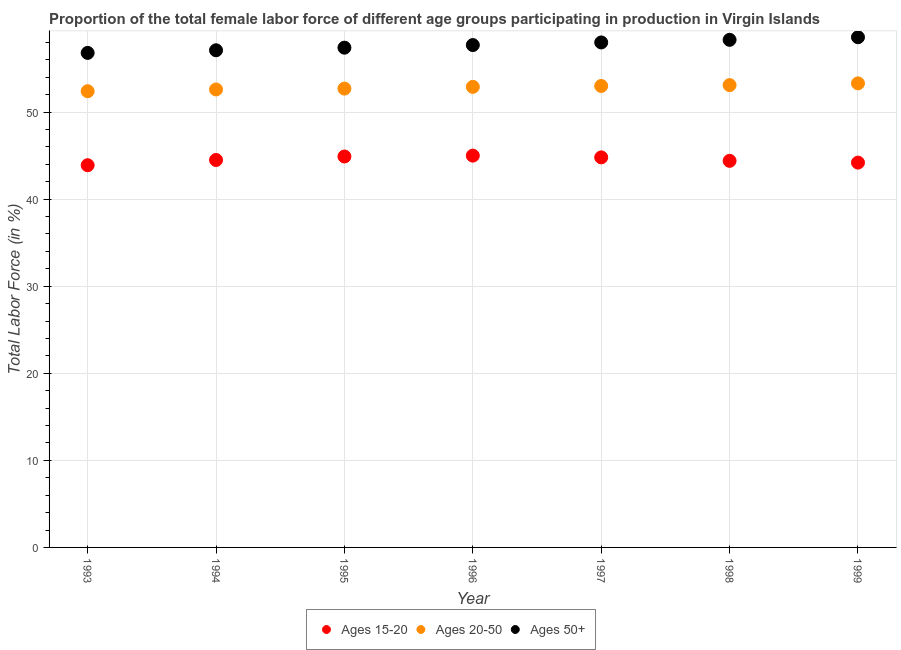How many different coloured dotlines are there?
Make the answer very short. 3. Is the number of dotlines equal to the number of legend labels?
Keep it short and to the point. Yes. What is the percentage of female labor force within the age group 20-50 in 1997?
Your answer should be compact. 53. Across all years, what is the maximum percentage of female labor force within the age group 15-20?
Keep it short and to the point. 45. Across all years, what is the minimum percentage of female labor force within the age group 20-50?
Keep it short and to the point. 52.4. What is the total percentage of female labor force within the age group 20-50 in the graph?
Keep it short and to the point. 370. What is the difference between the percentage of female labor force within the age group 15-20 in 1996 and that in 1997?
Offer a terse response. 0.2. What is the difference between the percentage of female labor force within the age group 15-20 in 1997 and the percentage of female labor force above age 50 in 1993?
Provide a succinct answer. -12. What is the average percentage of female labor force above age 50 per year?
Provide a short and direct response. 57.7. In the year 1997, what is the difference between the percentage of female labor force above age 50 and percentage of female labor force within the age group 15-20?
Make the answer very short. 13.2. What is the ratio of the percentage of female labor force within the age group 15-20 in 1995 to that in 1996?
Keep it short and to the point. 1. What is the difference between the highest and the second highest percentage of female labor force above age 50?
Offer a terse response. 0.3. What is the difference between the highest and the lowest percentage of female labor force within the age group 15-20?
Offer a very short reply. 1.1. Is the sum of the percentage of female labor force within the age group 20-50 in 1996 and 1997 greater than the maximum percentage of female labor force within the age group 15-20 across all years?
Your answer should be very brief. Yes. Is it the case that in every year, the sum of the percentage of female labor force within the age group 15-20 and percentage of female labor force within the age group 20-50 is greater than the percentage of female labor force above age 50?
Keep it short and to the point. Yes. Is the percentage of female labor force within the age group 20-50 strictly greater than the percentage of female labor force within the age group 15-20 over the years?
Offer a very short reply. Yes. How many dotlines are there?
Provide a short and direct response. 3. How many years are there in the graph?
Provide a short and direct response. 7. What is the difference between two consecutive major ticks on the Y-axis?
Keep it short and to the point. 10. Are the values on the major ticks of Y-axis written in scientific E-notation?
Keep it short and to the point. No. Does the graph contain any zero values?
Your response must be concise. No. How are the legend labels stacked?
Your answer should be very brief. Horizontal. What is the title of the graph?
Your answer should be compact. Proportion of the total female labor force of different age groups participating in production in Virgin Islands. Does "Private sector" appear as one of the legend labels in the graph?
Ensure brevity in your answer.  No. What is the label or title of the Y-axis?
Keep it short and to the point. Total Labor Force (in %). What is the Total Labor Force (in %) in Ages 15-20 in 1993?
Provide a succinct answer. 43.9. What is the Total Labor Force (in %) of Ages 20-50 in 1993?
Give a very brief answer. 52.4. What is the Total Labor Force (in %) in Ages 50+ in 1993?
Give a very brief answer. 56.8. What is the Total Labor Force (in %) of Ages 15-20 in 1994?
Offer a terse response. 44.5. What is the Total Labor Force (in %) in Ages 20-50 in 1994?
Make the answer very short. 52.6. What is the Total Labor Force (in %) of Ages 50+ in 1994?
Ensure brevity in your answer.  57.1. What is the Total Labor Force (in %) in Ages 15-20 in 1995?
Keep it short and to the point. 44.9. What is the Total Labor Force (in %) in Ages 20-50 in 1995?
Give a very brief answer. 52.7. What is the Total Labor Force (in %) of Ages 50+ in 1995?
Make the answer very short. 57.4. What is the Total Labor Force (in %) of Ages 20-50 in 1996?
Give a very brief answer. 52.9. What is the Total Labor Force (in %) in Ages 50+ in 1996?
Provide a succinct answer. 57.7. What is the Total Labor Force (in %) in Ages 15-20 in 1997?
Provide a succinct answer. 44.8. What is the Total Labor Force (in %) in Ages 50+ in 1997?
Offer a very short reply. 58. What is the Total Labor Force (in %) in Ages 15-20 in 1998?
Provide a short and direct response. 44.4. What is the Total Labor Force (in %) of Ages 20-50 in 1998?
Keep it short and to the point. 53.1. What is the Total Labor Force (in %) in Ages 50+ in 1998?
Make the answer very short. 58.3. What is the Total Labor Force (in %) in Ages 15-20 in 1999?
Provide a succinct answer. 44.2. What is the Total Labor Force (in %) of Ages 20-50 in 1999?
Make the answer very short. 53.3. What is the Total Labor Force (in %) in Ages 50+ in 1999?
Provide a succinct answer. 58.6. Across all years, what is the maximum Total Labor Force (in %) in Ages 15-20?
Give a very brief answer. 45. Across all years, what is the maximum Total Labor Force (in %) of Ages 20-50?
Provide a succinct answer. 53.3. Across all years, what is the maximum Total Labor Force (in %) in Ages 50+?
Provide a short and direct response. 58.6. Across all years, what is the minimum Total Labor Force (in %) of Ages 15-20?
Offer a terse response. 43.9. Across all years, what is the minimum Total Labor Force (in %) in Ages 20-50?
Keep it short and to the point. 52.4. Across all years, what is the minimum Total Labor Force (in %) in Ages 50+?
Offer a very short reply. 56.8. What is the total Total Labor Force (in %) of Ages 15-20 in the graph?
Keep it short and to the point. 311.7. What is the total Total Labor Force (in %) in Ages 20-50 in the graph?
Offer a terse response. 370. What is the total Total Labor Force (in %) of Ages 50+ in the graph?
Offer a terse response. 403.9. What is the difference between the Total Labor Force (in %) of Ages 15-20 in 1993 and that in 1994?
Give a very brief answer. -0.6. What is the difference between the Total Labor Force (in %) in Ages 20-50 in 1993 and that in 1994?
Offer a terse response. -0.2. What is the difference between the Total Labor Force (in %) in Ages 50+ in 1993 and that in 1995?
Your response must be concise. -0.6. What is the difference between the Total Labor Force (in %) in Ages 15-20 in 1993 and that in 1996?
Ensure brevity in your answer.  -1.1. What is the difference between the Total Labor Force (in %) of Ages 20-50 in 1993 and that in 1996?
Your response must be concise. -0.5. What is the difference between the Total Labor Force (in %) in Ages 15-20 in 1993 and that in 1997?
Ensure brevity in your answer.  -0.9. What is the difference between the Total Labor Force (in %) in Ages 20-50 in 1993 and that in 1997?
Keep it short and to the point. -0.6. What is the difference between the Total Labor Force (in %) in Ages 15-20 in 1993 and that in 1998?
Keep it short and to the point. -0.5. What is the difference between the Total Labor Force (in %) of Ages 20-50 in 1993 and that in 1998?
Make the answer very short. -0.7. What is the difference between the Total Labor Force (in %) of Ages 15-20 in 1993 and that in 1999?
Offer a very short reply. -0.3. What is the difference between the Total Labor Force (in %) of Ages 20-50 in 1993 and that in 1999?
Provide a succinct answer. -0.9. What is the difference between the Total Labor Force (in %) in Ages 15-20 in 1994 and that in 1995?
Ensure brevity in your answer.  -0.4. What is the difference between the Total Labor Force (in %) of Ages 20-50 in 1994 and that in 1995?
Your response must be concise. -0.1. What is the difference between the Total Labor Force (in %) of Ages 20-50 in 1994 and that in 1997?
Ensure brevity in your answer.  -0.4. What is the difference between the Total Labor Force (in %) of Ages 50+ in 1994 and that in 1997?
Your answer should be very brief. -0.9. What is the difference between the Total Labor Force (in %) of Ages 20-50 in 1994 and that in 1998?
Offer a terse response. -0.5. What is the difference between the Total Labor Force (in %) of Ages 50+ in 1994 and that in 1998?
Make the answer very short. -1.2. What is the difference between the Total Labor Force (in %) of Ages 20-50 in 1994 and that in 1999?
Make the answer very short. -0.7. What is the difference between the Total Labor Force (in %) of Ages 50+ in 1994 and that in 1999?
Your response must be concise. -1.5. What is the difference between the Total Labor Force (in %) of Ages 15-20 in 1995 and that in 1996?
Your answer should be compact. -0.1. What is the difference between the Total Labor Force (in %) of Ages 20-50 in 1995 and that in 1996?
Offer a very short reply. -0.2. What is the difference between the Total Labor Force (in %) in Ages 50+ in 1995 and that in 1996?
Offer a terse response. -0.3. What is the difference between the Total Labor Force (in %) in Ages 15-20 in 1995 and that in 1997?
Keep it short and to the point. 0.1. What is the difference between the Total Labor Force (in %) of Ages 50+ in 1995 and that in 1997?
Your answer should be very brief. -0.6. What is the difference between the Total Labor Force (in %) of Ages 20-50 in 1995 and that in 1998?
Make the answer very short. -0.4. What is the difference between the Total Labor Force (in %) of Ages 50+ in 1995 and that in 1998?
Make the answer very short. -0.9. What is the difference between the Total Labor Force (in %) in Ages 20-50 in 1995 and that in 1999?
Your response must be concise. -0.6. What is the difference between the Total Labor Force (in %) in Ages 50+ in 1995 and that in 1999?
Your answer should be very brief. -1.2. What is the difference between the Total Labor Force (in %) in Ages 20-50 in 1996 and that in 1998?
Provide a short and direct response. -0.2. What is the difference between the Total Labor Force (in %) in Ages 50+ in 1996 and that in 1998?
Your answer should be compact. -0.6. What is the difference between the Total Labor Force (in %) of Ages 15-20 in 1996 and that in 1999?
Your answer should be very brief. 0.8. What is the difference between the Total Labor Force (in %) of Ages 50+ in 1996 and that in 1999?
Give a very brief answer. -0.9. What is the difference between the Total Labor Force (in %) in Ages 50+ in 1997 and that in 1998?
Provide a succinct answer. -0.3. What is the difference between the Total Labor Force (in %) in Ages 50+ in 1998 and that in 1999?
Give a very brief answer. -0.3. What is the difference between the Total Labor Force (in %) of Ages 15-20 in 1993 and the Total Labor Force (in %) of Ages 50+ in 1995?
Ensure brevity in your answer.  -13.5. What is the difference between the Total Labor Force (in %) of Ages 20-50 in 1993 and the Total Labor Force (in %) of Ages 50+ in 1995?
Provide a short and direct response. -5. What is the difference between the Total Labor Force (in %) of Ages 15-20 in 1993 and the Total Labor Force (in %) of Ages 20-50 in 1996?
Offer a terse response. -9. What is the difference between the Total Labor Force (in %) in Ages 15-20 in 1993 and the Total Labor Force (in %) in Ages 50+ in 1996?
Provide a short and direct response. -13.8. What is the difference between the Total Labor Force (in %) of Ages 15-20 in 1993 and the Total Labor Force (in %) of Ages 20-50 in 1997?
Your response must be concise. -9.1. What is the difference between the Total Labor Force (in %) in Ages 15-20 in 1993 and the Total Labor Force (in %) in Ages 50+ in 1997?
Offer a very short reply. -14.1. What is the difference between the Total Labor Force (in %) in Ages 15-20 in 1993 and the Total Labor Force (in %) in Ages 20-50 in 1998?
Offer a terse response. -9.2. What is the difference between the Total Labor Force (in %) in Ages 15-20 in 1993 and the Total Labor Force (in %) in Ages 50+ in 1998?
Provide a succinct answer. -14.4. What is the difference between the Total Labor Force (in %) in Ages 15-20 in 1993 and the Total Labor Force (in %) in Ages 50+ in 1999?
Your response must be concise. -14.7. What is the difference between the Total Labor Force (in %) of Ages 20-50 in 1993 and the Total Labor Force (in %) of Ages 50+ in 1999?
Your answer should be compact. -6.2. What is the difference between the Total Labor Force (in %) of Ages 15-20 in 1994 and the Total Labor Force (in %) of Ages 20-50 in 1995?
Provide a short and direct response. -8.2. What is the difference between the Total Labor Force (in %) of Ages 20-50 in 1994 and the Total Labor Force (in %) of Ages 50+ in 1995?
Provide a succinct answer. -4.8. What is the difference between the Total Labor Force (in %) in Ages 15-20 in 1994 and the Total Labor Force (in %) in Ages 50+ in 1996?
Offer a very short reply. -13.2. What is the difference between the Total Labor Force (in %) of Ages 20-50 in 1994 and the Total Labor Force (in %) of Ages 50+ in 1997?
Offer a very short reply. -5.4. What is the difference between the Total Labor Force (in %) in Ages 15-20 in 1994 and the Total Labor Force (in %) in Ages 50+ in 1999?
Keep it short and to the point. -14.1. What is the difference between the Total Labor Force (in %) of Ages 20-50 in 1994 and the Total Labor Force (in %) of Ages 50+ in 1999?
Offer a terse response. -6. What is the difference between the Total Labor Force (in %) of Ages 15-20 in 1995 and the Total Labor Force (in %) of Ages 20-50 in 1996?
Ensure brevity in your answer.  -8. What is the difference between the Total Labor Force (in %) in Ages 20-50 in 1995 and the Total Labor Force (in %) in Ages 50+ in 1996?
Offer a very short reply. -5. What is the difference between the Total Labor Force (in %) of Ages 15-20 in 1995 and the Total Labor Force (in %) of Ages 50+ in 1997?
Provide a short and direct response. -13.1. What is the difference between the Total Labor Force (in %) of Ages 15-20 in 1995 and the Total Labor Force (in %) of Ages 50+ in 1999?
Offer a very short reply. -13.7. What is the difference between the Total Labor Force (in %) of Ages 15-20 in 1996 and the Total Labor Force (in %) of Ages 50+ in 1997?
Offer a very short reply. -13. What is the difference between the Total Labor Force (in %) in Ages 20-50 in 1996 and the Total Labor Force (in %) in Ages 50+ in 1997?
Your answer should be very brief. -5.1. What is the difference between the Total Labor Force (in %) in Ages 15-20 in 1996 and the Total Labor Force (in %) in Ages 20-50 in 1998?
Keep it short and to the point. -8.1. What is the difference between the Total Labor Force (in %) in Ages 15-20 in 1996 and the Total Labor Force (in %) in Ages 50+ in 1998?
Provide a succinct answer. -13.3. What is the difference between the Total Labor Force (in %) in Ages 20-50 in 1996 and the Total Labor Force (in %) in Ages 50+ in 1999?
Your answer should be very brief. -5.7. What is the difference between the Total Labor Force (in %) of Ages 15-20 in 1997 and the Total Labor Force (in %) of Ages 50+ in 1998?
Your answer should be very brief. -13.5. What is the difference between the Total Labor Force (in %) in Ages 20-50 in 1997 and the Total Labor Force (in %) in Ages 50+ in 1999?
Offer a terse response. -5.6. What is the difference between the Total Labor Force (in %) in Ages 15-20 in 1998 and the Total Labor Force (in %) in Ages 50+ in 1999?
Your answer should be compact. -14.2. What is the difference between the Total Labor Force (in %) in Ages 20-50 in 1998 and the Total Labor Force (in %) in Ages 50+ in 1999?
Ensure brevity in your answer.  -5.5. What is the average Total Labor Force (in %) of Ages 15-20 per year?
Your response must be concise. 44.53. What is the average Total Labor Force (in %) of Ages 20-50 per year?
Your response must be concise. 52.86. What is the average Total Labor Force (in %) of Ages 50+ per year?
Your answer should be very brief. 57.7. In the year 1993, what is the difference between the Total Labor Force (in %) in Ages 15-20 and Total Labor Force (in %) in Ages 50+?
Provide a succinct answer. -12.9. In the year 1993, what is the difference between the Total Labor Force (in %) of Ages 20-50 and Total Labor Force (in %) of Ages 50+?
Give a very brief answer. -4.4. In the year 1994, what is the difference between the Total Labor Force (in %) of Ages 15-20 and Total Labor Force (in %) of Ages 20-50?
Make the answer very short. -8.1. In the year 1995, what is the difference between the Total Labor Force (in %) in Ages 15-20 and Total Labor Force (in %) in Ages 20-50?
Your answer should be compact. -7.8. In the year 1995, what is the difference between the Total Labor Force (in %) in Ages 15-20 and Total Labor Force (in %) in Ages 50+?
Your response must be concise. -12.5. In the year 1995, what is the difference between the Total Labor Force (in %) in Ages 20-50 and Total Labor Force (in %) in Ages 50+?
Your answer should be compact. -4.7. In the year 1996, what is the difference between the Total Labor Force (in %) in Ages 15-20 and Total Labor Force (in %) in Ages 50+?
Ensure brevity in your answer.  -12.7. In the year 1996, what is the difference between the Total Labor Force (in %) of Ages 20-50 and Total Labor Force (in %) of Ages 50+?
Provide a short and direct response. -4.8. In the year 1997, what is the difference between the Total Labor Force (in %) of Ages 15-20 and Total Labor Force (in %) of Ages 50+?
Ensure brevity in your answer.  -13.2. In the year 1997, what is the difference between the Total Labor Force (in %) in Ages 20-50 and Total Labor Force (in %) in Ages 50+?
Provide a succinct answer. -5. In the year 1998, what is the difference between the Total Labor Force (in %) of Ages 15-20 and Total Labor Force (in %) of Ages 20-50?
Your answer should be very brief. -8.7. In the year 1998, what is the difference between the Total Labor Force (in %) of Ages 15-20 and Total Labor Force (in %) of Ages 50+?
Offer a very short reply. -13.9. In the year 1999, what is the difference between the Total Labor Force (in %) in Ages 15-20 and Total Labor Force (in %) in Ages 20-50?
Provide a short and direct response. -9.1. In the year 1999, what is the difference between the Total Labor Force (in %) of Ages 15-20 and Total Labor Force (in %) of Ages 50+?
Ensure brevity in your answer.  -14.4. In the year 1999, what is the difference between the Total Labor Force (in %) in Ages 20-50 and Total Labor Force (in %) in Ages 50+?
Offer a terse response. -5.3. What is the ratio of the Total Labor Force (in %) in Ages 15-20 in 1993 to that in 1994?
Keep it short and to the point. 0.99. What is the ratio of the Total Labor Force (in %) in Ages 15-20 in 1993 to that in 1995?
Your answer should be very brief. 0.98. What is the ratio of the Total Labor Force (in %) in Ages 20-50 in 1993 to that in 1995?
Your answer should be compact. 0.99. What is the ratio of the Total Labor Force (in %) of Ages 50+ in 1993 to that in 1995?
Your answer should be compact. 0.99. What is the ratio of the Total Labor Force (in %) in Ages 15-20 in 1993 to that in 1996?
Keep it short and to the point. 0.98. What is the ratio of the Total Labor Force (in %) of Ages 20-50 in 1993 to that in 1996?
Your answer should be compact. 0.99. What is the ratio of the Total Labor Force (in %) in Ages 50+ in 1993 to that in 1996?
Offer a very short reply. 0.98. What is the ratio of the Total Labor Force (in %) of Ages 15-20 in 1993 to that in 1997?
Offer a terse response. 0.98. What is the ratio of the Total Labor Force (in %) in Ages 20-50 in 1993 to that in 1997?
Give a very brief answer. 0.99. What is the ratio of the Total Labor Force (in %) of Ages 50+ in 1993 to that in 1997?
Ensure brevity in your answer.  0.98. What is the ratio of the Total Labor Force (in %) in Ages 15-20 in 1993 to that in 1998?
Offer a very short reply. 0.99. What is the ratio of the Total Labor Force (in %) of Ages 50+ in 1993 to that in 1998?
Your answer should be very brief. 0.97. What is the ratio of the Total Labor Force (in %) of Ages 20-50 in 1993 to that in 1999?
Offer a terse response. 0.98. What is the ratio of the Total Labor Force (in %) of Ages 50+ in 1993 to that in 1999?
Provide a short and direct response. 0.97. What is the ratio of the Total Labor Force (in %) in Ages 20-50 in 1994 to that in 1995?
Offer a terse response. 1. What is the ratio of the Total Labor Force (in %) in Ages 50+ in 1994 to that in 1995?
Make the answer very short. 0.99. What is the ratio of the Total Labor Force (in %) of Ages 15-20 in 1994 to that in 1996?
Offer a terse response. 0.99. What is the ratio of the Total Labor Force (in %) of Ages 15-20 in 1994 to that in 1997?
Offer a very short reply. 0.99. What is the ratio of the Total Labor Force (in %) of Ages 50+ in 1994 to that in 1997?
Ensure brevity in your answer.  0.98. What is the ratio of the Total Labor Force (in %) in Ages 20-50 in 1994 to that in 1998?
Your response must be concise. 0.99. What is the ratio of the Total Labor Force (in %) of Ages 50+ in 1994 to that in 1998?
Give a very brief answer. 0.98. What is the ratio of the Total Labor Force (in %) of Ages 15-20 in 1994 to that in 1999?
Keep it short and to the point. 1.01. What is the ratio of the Total Labor Force (in %) of Ages 20-50 in 1994 to that in 1999?
Your answer should be very brief. 0.99. What is the ratio of the Total Labor Force (in %) in Ages 50+ in 1994 to that in 1999?
Your answer should be compact. 0.97. What is the ratio of the Total Labor Force (in %) in Ages 20-50 in 1995 to that in 1996?
Offer a terse response. 1. What is the ratio of the Total Labor Force (in %) of Ages 50+ in 1995 to that in 1996?
Keep it short and to the point. 0.99. What is the ratio of the Total Labor Force (in %) in Ages 15-20 in 1995 to that in 1997?
Keep it short and to the point. 1. What is the ratio of the Total Labor Force (in %) in Ages 15-20 in 1995 to that in 1998?
Offer a terse response. 1.01. What is the ratio of the Total Labor Force (in %) of Ages 20-50 in 1995 to that in 1998?
Your answer should be very brief. 0.99. What is the ratio of the Total Labor Force (in %) of Ages 50+ in 1995 to that in 1998?
Ensure brevity in your answer.  0.98. What is the ratio of the Total Labor Force (in %) in Ages 15-20 in 1995 to that in 1999?
Make the answer very short. 1.02. What is the ratio of the Total Labor Force (in %) of Ages 20-50 in 1995 to that in 1999?
Your answer should be very brief. 0.99. What is the ratio of the Total Labor Force (in %) in Ages 50+ in 1995 to that in 1999?
Give a very brief answer. 0.98. What is the ratio of the Total Labor Force (in %) in Ages 15-20 in 1996 to that in 1997?
Keep it short and to the point. 1. What is the ratio of the Total Labor Force (in %) of Ages 15-20 in 1996 to that in 1998?
Provide a succinct answer. 1.01. What is the ratio of the Total Labor Force (in %) in Ages 20-50 in 1996 to that in 1998?
Ensure brevity in your answer.  1. What is the ratio of the Total Labor Force (in %) in Ages 50+ in 1996 to that in 1998?
Offer a terse response. 0.99. What is the ratio of the Total Labor Force (in %) of Ages 15-20 in 1996 to that in 1999?
Your response must be concise. 1.02. What is the ratio of the Total Labor Force (in %) in Ages 50+ in 1996 to that in 1999?
Your answer should be very brief. 0.98. What is the ratio of the Total Labor Force (in %) of Ages 20-50 in 1997 to that in 1998?
Offer a very short reply. 1. What is the ratio of the Total Labor Force (in %) in Ages 15-20 in 1997 to that in 1999?
Give a very brief answer. 1.01. What is the ratio of the Total Labor Force (in %) in Ages 50+ in 1997 to that in 1999?
Keep it short and to the point. 0.99. What is the ratio of the Total Labor Force (in %) in Ages 15-20 in 1998 to that in 1999?
Your answer should be compact. 1. What is the ratio of the Total Labor Force (in %) of Ages 20-50 in 1998 to that in 1999?
Give a very brief answer. 1. What is the difference between the highest and the lowest Total Labor Force (in %) in Ages 50+?
Provide a succinct answer. 1.8. 